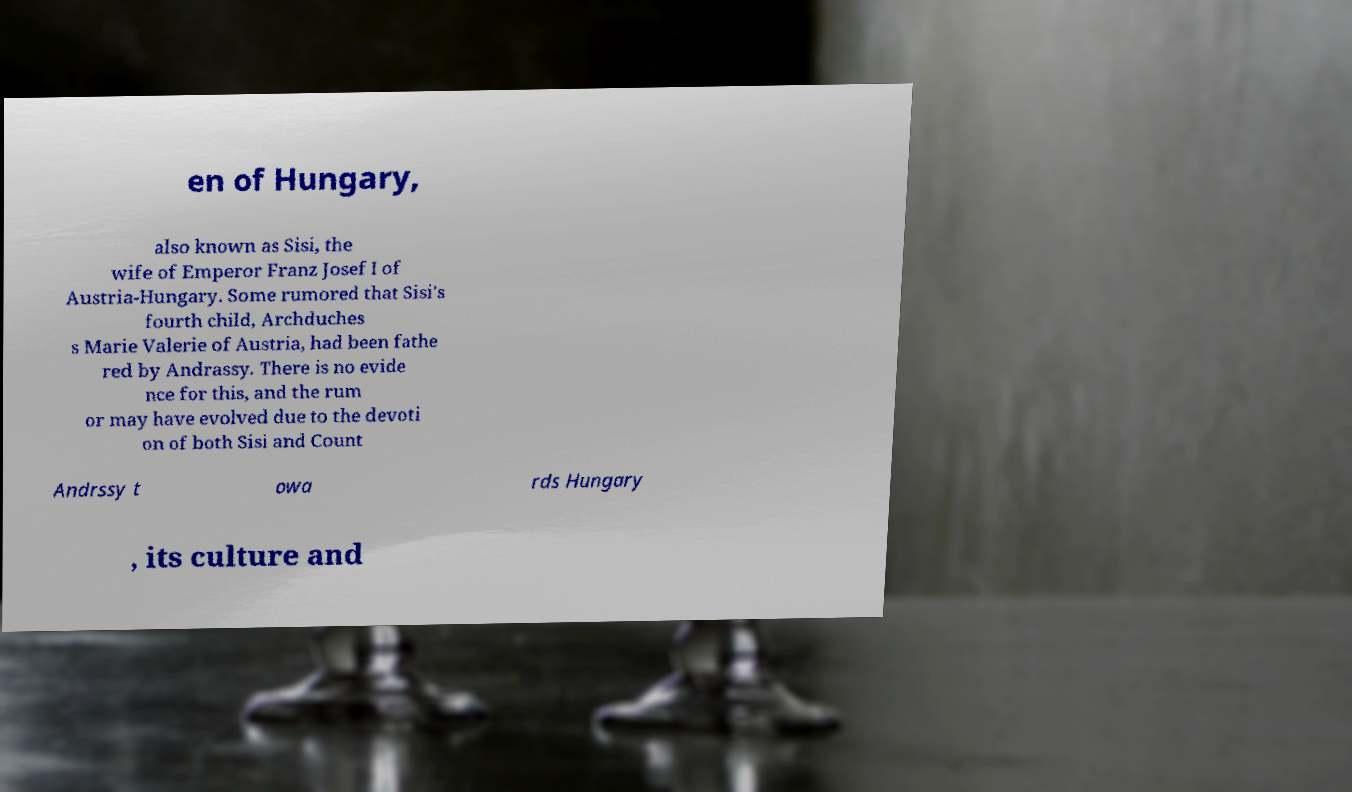Please identify and transcribe the text found in this image. en of Hungary, also known as Sisi, the wife of Emperor Franz Josef I of Austria-Hungary. Some rumored that Sisi's fourth child, Archduches s Marie Valerie of Austria, had been fathe red by Andrassy. There is no evide nce for this, and the rum or may have evolved due to the devoti on of both Sisi and Count Andrssy t owa rds Hungary , its culture and 